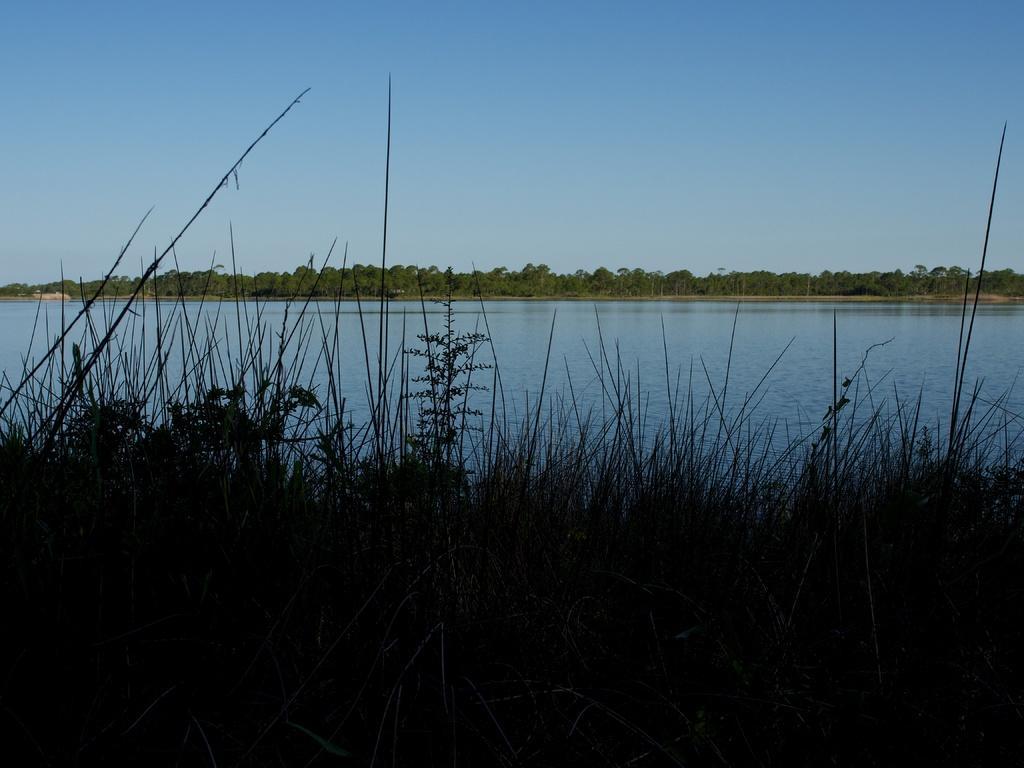How would you summarize this image in a sentence or two? This is outdoor picture. In front of the picture we can see planets and this is a grass. This is a river with fresh blue water. We can see the trees here. On the background there is a clear blue sky and it seems like a windy day. 